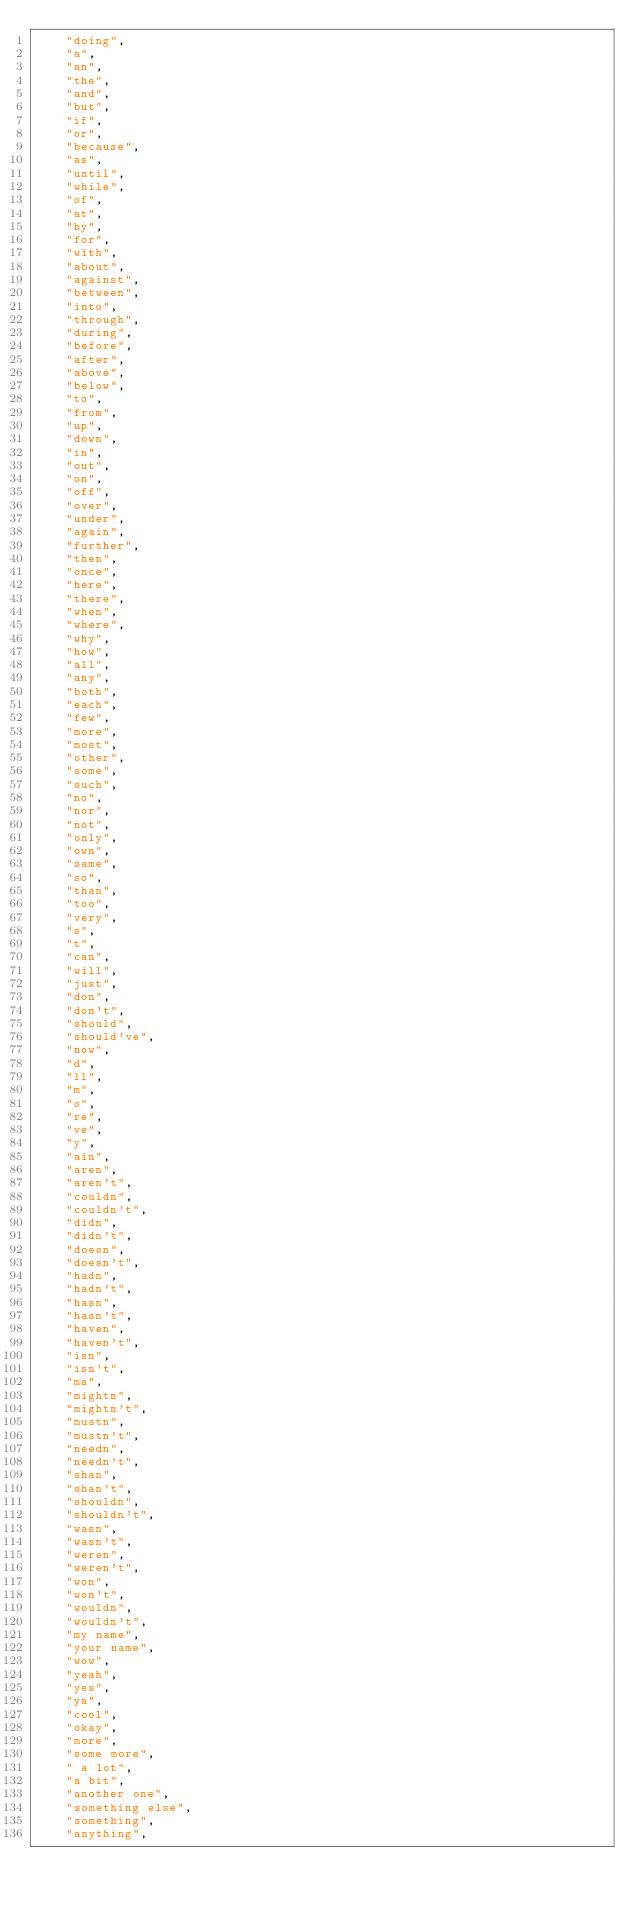<code> <loc_0><loc_0><loc_500><loc_500><_Python_>    "doing",
    "a",
    "an",
    "the",
    "and",
    "but",
    "if",
    "or",
    "because",
    "as",
    "until",
    "while",
    "of",
    "at",
    "by",
    "for",
    "with",
    "about",
    "against",
    "between",
    "into",
    "through",
    "during",
    "before",
    "after",
    "above",
    "below",
    "to",
    "from",
    "up",
    "down",
    "in",
    "out",
    "on",
    "off",
    "over",
    "under",
    "again",
    "further",
    "then",
    "once",
    "here",
    "there",
    "when",
    "where",
    "why",
    "how",
    "all",
    "any",
    "both",
    "each",
    "few",
    "more",
    "most",
    "other",
    "some",
    "such",
    "no",
    "nor",
    "not",
    "only",
    "own",
    "same",
    "so",
    "than",
    "too",
    "very",
    "s",
    "t",
    "can",
    "will",
    "just",
    "don",
    "don't",
    "should",
    "should've",
    "now",
    "d",
    "ll",
    "m",
    "o",
    "re",
    "ve",
    "y",
    "ain",
    "aren",
    "aren't",
    "couldn",
    "couldn't",
    "didn",
    "didn't",
    "doesn",
    "doesn't",
    "hadn",
    "hadn't",
    "hasn",
    "hasn't",
    "haven",
    "haven't",
    "isn",
    "isn't",
    "ma",
    "mightn",
    "mightn't",
    "mustn",
    "mustn't",
    "needn",
    "needn't",
    "shan",
    "shan't",
    "shouldn",
    "shouldn't",
    "wasn",
    "wasn't",
    "weren",
    "weren't",
    "won",
    "won't",
    "wouldn",
    "wouldn't",
    "my name",
    "your name",
    "wow",
    "yeah",
    "yes",
    "ya",
    "cool",
    "okay",
    "more",
    "some more",
    " a lot",
    "a bit",
    "another one",
    "something else",
    "something",
    "anything",</code> 